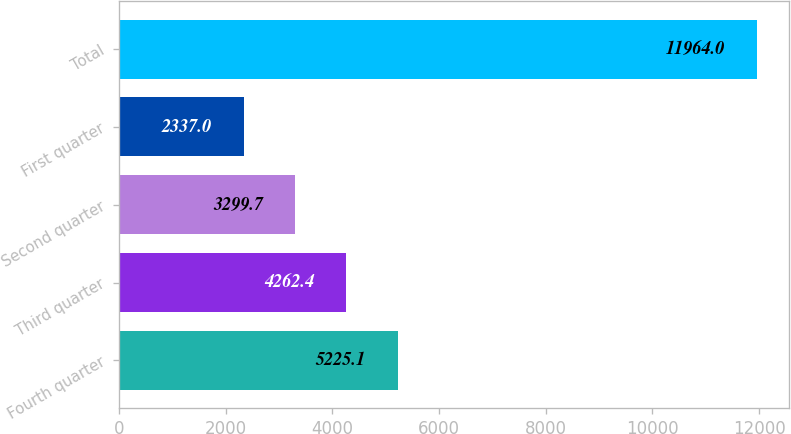Convert chart. <chart><loc_0><loc_0><loc_500><loc_500><bar_chart><fcel>Fourth quarter<fcel>Third quarter<fcel>Second quarter<fcel>First quarter<fcel>Total<nl><fcel>5225.1<fcel>4262.4<fcel>3299.7<fcel>2337<fcel>11964<nl></chart> 